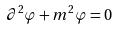<formula> <loc_0><loc_0><loc_500><loc_500>\partial ^ { 2 } \varphi + m ^ { 2 } \varphi = 0</formula> 